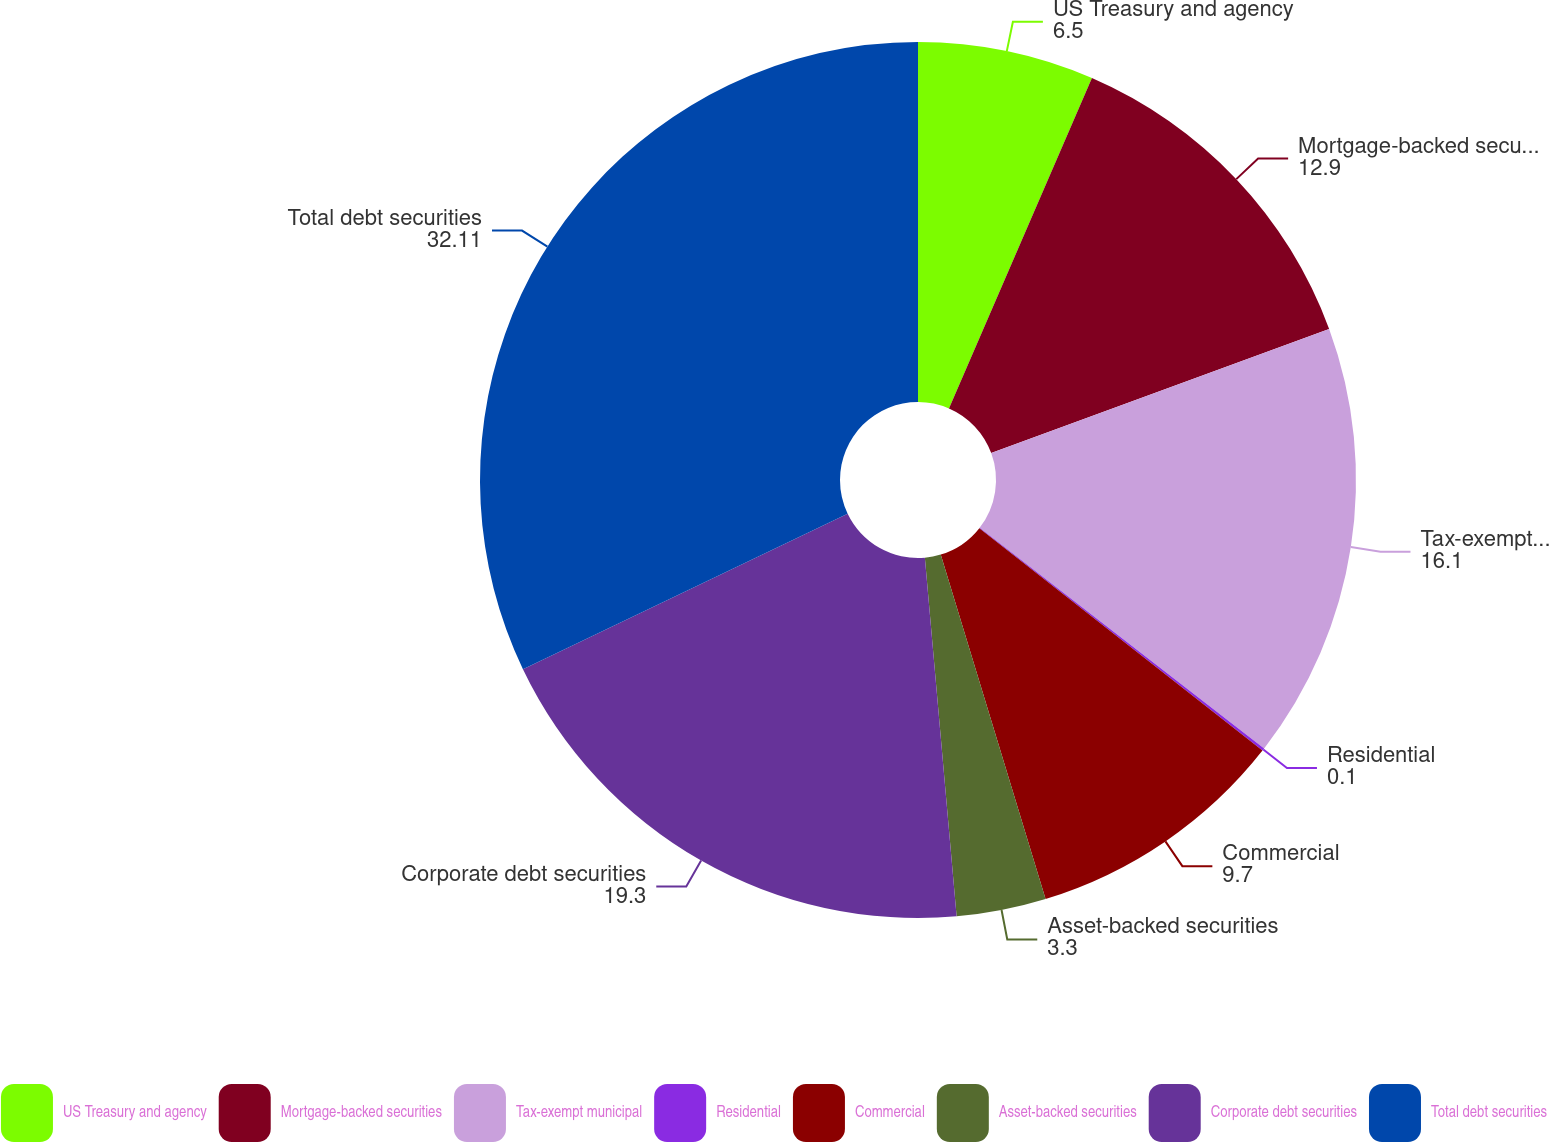Convert chart. <chart><loc_0><loc_0><loc_500><loc_500><pie_chart><fcel>US Treasury and agency<fcel>Mortgage-backed securities<fcel>Tax-exempt municipal<fcel>Residential<fcel>Commercial<fcel>Asset-backed securities<fcel>Corporate debt securities<fcel>Total debt securities<nl><fcel>6.5%<fcel>12.9%<fcel>16.1%<fcel>0.1%<fcel>9.7%<fcel>3.3%<fcel>19.3%<fcel>32.11%<nl></chart> 